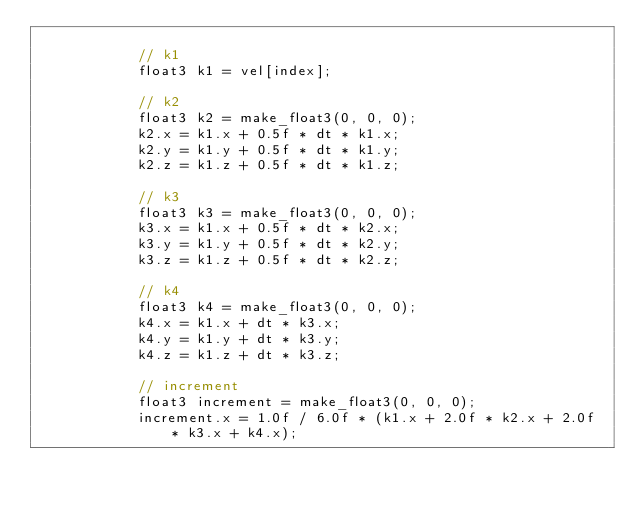<code> <loc_0><loc_0><loc_500><loc_500><_Cuda_>
			// k1
			float3 k1 = vel[index];

			// k2
			float3 k2 = make_float3(0, 0, 0);
			k2.x = k1.x + 0.5f * dt * k1.x;
			k2.y = k1.y + 0.5f * dt * k1.y;
			k2.z = k1.z + 0.5f * dt * k1.z;

			// k3
			float3 k3 = make_float3(0, 0, 0);
			k3.x = k1.x + 0.5f * dt * k2.x;
			k3.y = k1.y + 0.5f * dt * k2.y;
			k3.z = k1.z + 0.5f * dt * k2.z;

			// k4
			float3 k4 = make_float3(0, 0, 0);
			k4.x = k1.x + dt * k3.x;
			k4.y = k1.y + dt * k3.y;
			k4.z = k1.z + dt * k3.z;

			// increment
			float3 increment = make_float3(0, 0, 0);
			increment.x = 1.0f / 6.0f * (k1.x + 2.0f * k2.x + 2.0f * k3.x + k4.x);</code> 